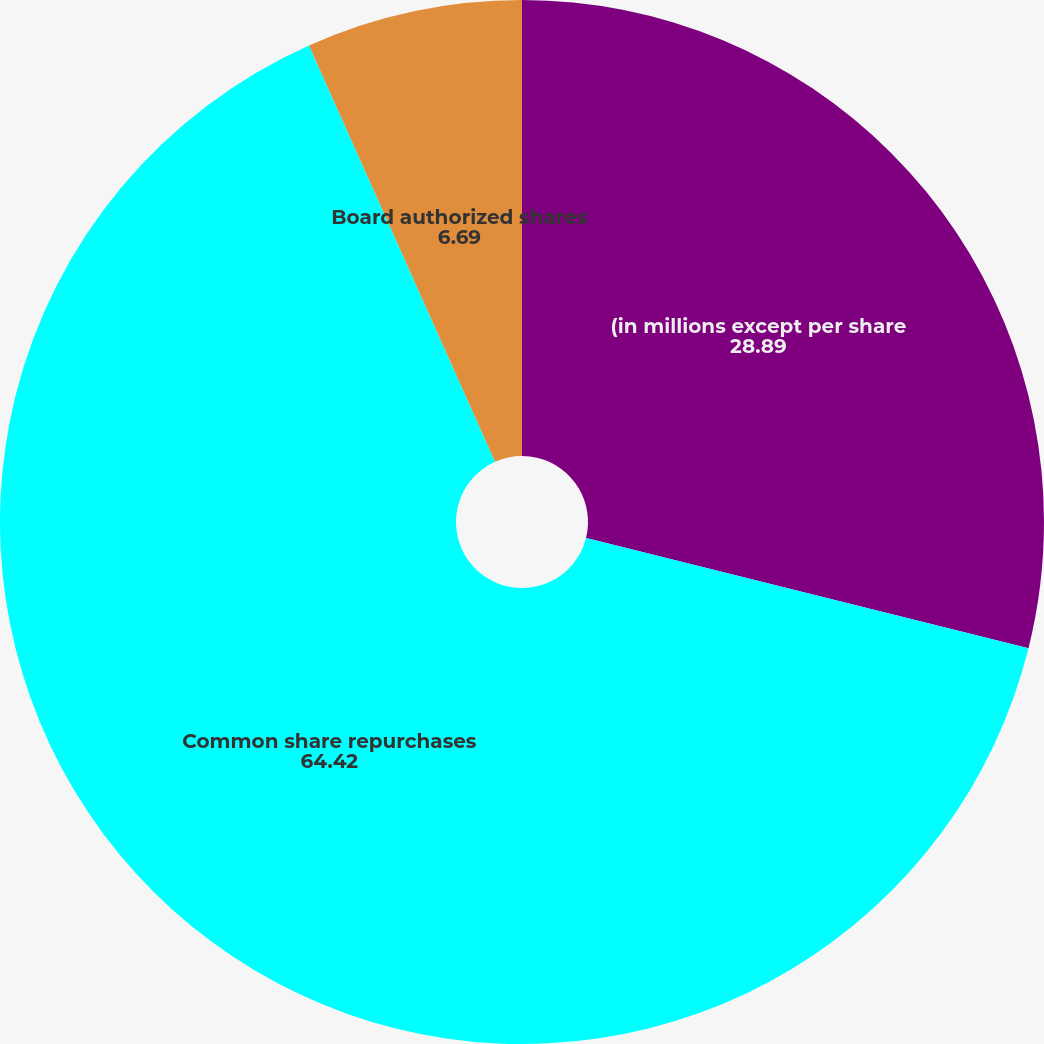<chart> <loc_0><loc_0><loc_500><loc_500><pie_chart><fcel>(in millions except per share<fcel>Common share repurchases<fcel>Board authorized shares<nl><fcel>28.89%<fcel>64.42%<fcel>6.69%<nl></chart> 